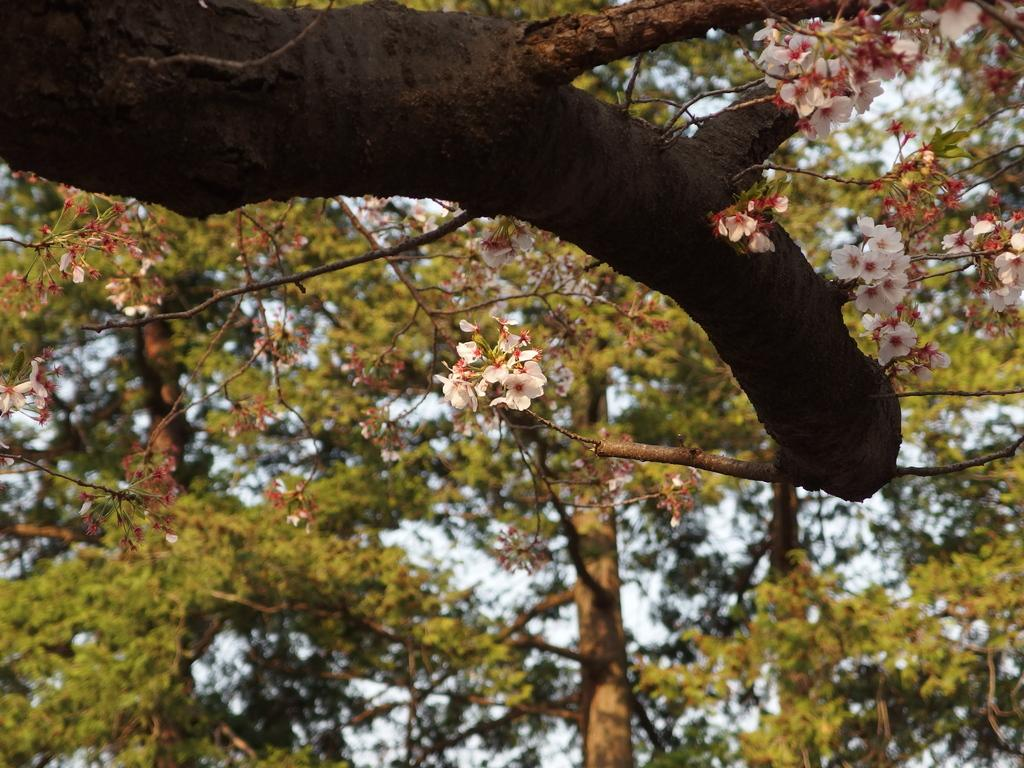What is present in the picture? There is a tree in the picture. Can you describe the tree's appearance? The tree has leaves and white flowers with pink color buds. What type of chair is being used during the protest in the image? There is no chair or protest present in the image; it features a tree with leaves and white flowers with pink color buds. 